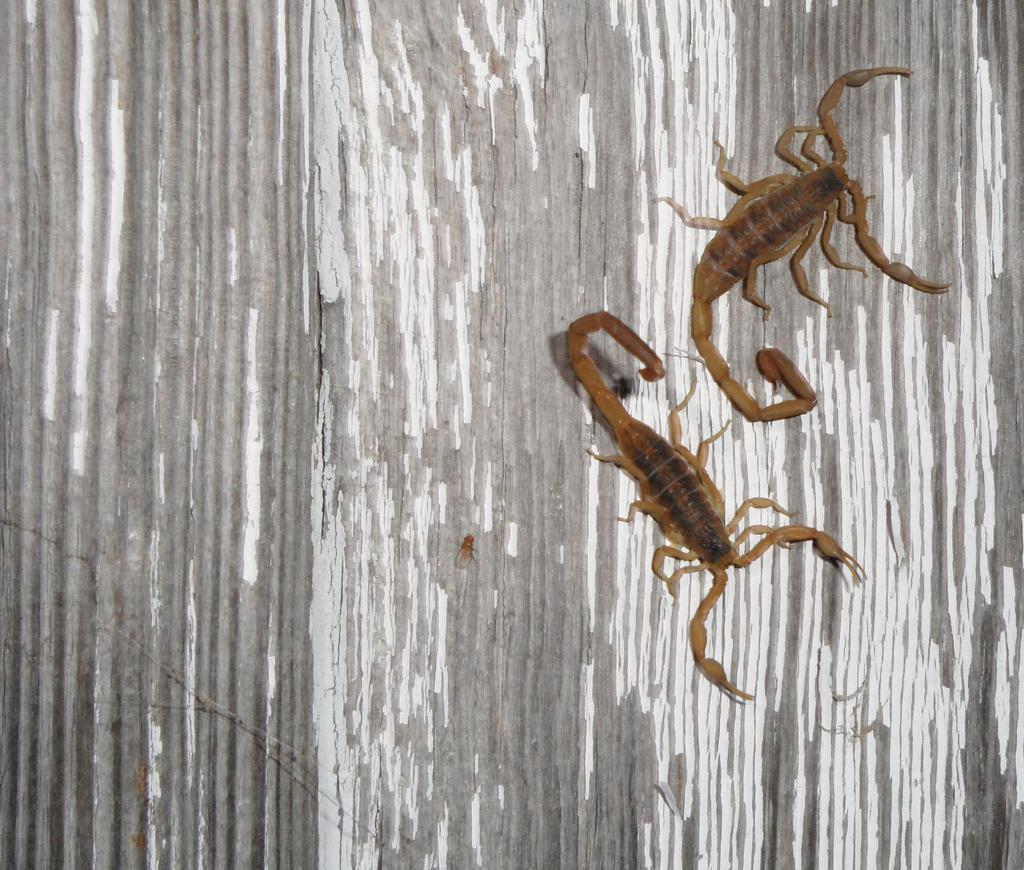How many scorpions are present in the image? There are two scorpions in the image. What is the color of the surface the scorpions are on? The surface has a grey and white color. What type of cork can be seen in the image? There is no cork present in the image; it features two scorpions on a grey and white surface. 